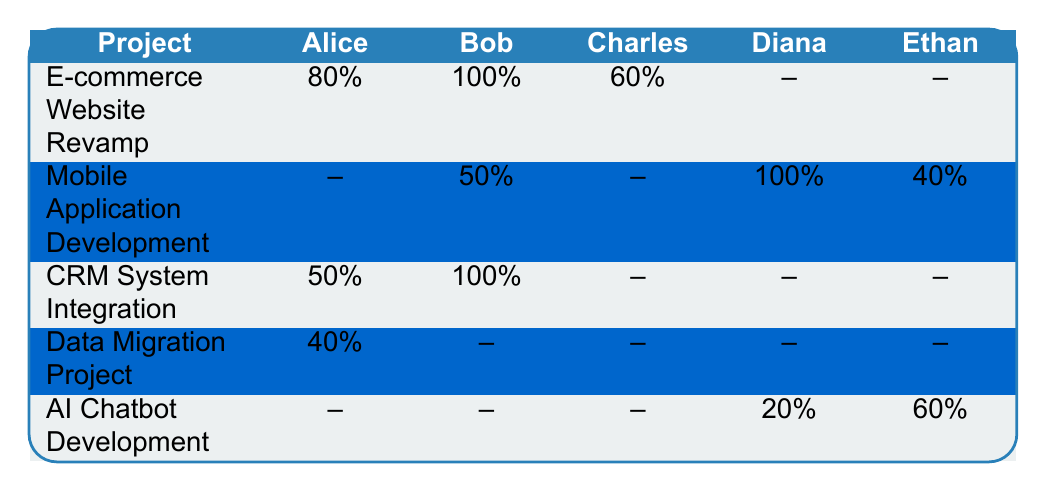What is the allocation percentage for Alice in the E-commerce Website Revamp project? The table shows that Alice's allocation for the E-commerce Website Revamp project is listed as 80%.
Answer: 80% What are the roles of the resources assigned to the Mobile Application Development project? The table indicates three resources: Bob Smith as a Back-end Developer, Diana Morales as a Mobile Developer, and Ethan Brown as a QA Tester.
Answer: Back-end Developer, Mobile Developer, QA Tester Which project has the maximum resource allocation for Bob? Bob has 100% allocation in the E-commerce Website Revamp project and 100% allocation in the CRM System Integration project; hence both have maximum allocation for Bob.
Answer: E-commerce Website Revamp and CRM System Integration In which project does Diana have a 100% allocation? According to the table, Diana Morales has a 100% allocation in the Mobile Application Development project.
Answer: Mobile Application Development What is the average allocation percentage for Alice across projects P001 and P003? Alice's allocations are 80% in P001 and 50% in P003. The average is (80 + 50)/2 = 65%.
Answer: 65% Does Ethan work on the CRM System Integration project? The table shows that there is no allocation for Ethan in the CRM System Integration project, indicating he does not work on it.
Answer: No Which project has the lowest total number of allocated resources? The Data Migration Project only has two allocated resources: Alice Johnson and George Harris, which is the lowest compared to other projects.
Answer: Data Migration Project For the AI Chatbot Development project, what is the combined allocation of Diana and Ethan? Diana has a 20% allocation and Ethan has a 60% allocation in the AI Chatbot Development project. Their combined allocation is 20% + 60% = 80%.
Answer: 80% Which project has overlapping resource allocation with Bob? Bob is allocated 100% in both the E-commerce Website Revamp and CRM System Integration projects, thus creating an overlap.
Answer: E-commerce Website Revamp and CRM System Integration How many projects have Charles as a resource? The table indicates Charles is a resource only in the E-commerce Website Revamp project, showing he is involved in just one project.
Answer: 1 